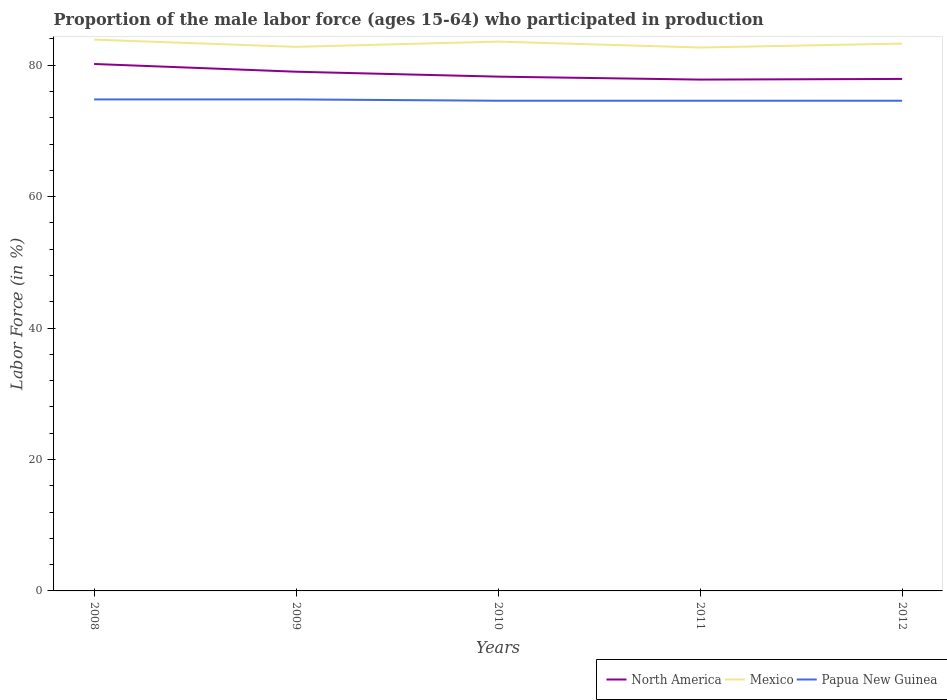How many different coloured lines are there?
Make the answer very short. 3. Across all years, what is the maximum proportion of the male labor force who participated in production in North America?
Your response must be concise. 77.82. In which year was the proportion of the male labor force who participated in production in North America maximum?
Keep it short and to the point. 2011. What is the total proportion of the male labor force who participated in production in North America in the graph?
Your answer should be very brief. -0.1. What is the difference between the highest and the second highest proportion of the male labor force who participated in production in Mexico?
Your answer should be very brief. 1.2. How many years are there in the graph?
Keep it short and to the point. 5. What is the difference between two consecutive major ticks on the Y-axis?
Offer a very short reply. 20. Does the graph contain any zero values?
Give a very brief answer. No. Where does the legend appear in the graph?
Your answer should be very brief. Bottom right. How many legend labels are there?
Give a very brief answer. 3. How are the legend labels stacked?
Ensure brevity in your answer.  Horizontal. What is the title of the graph?
Make the answer very short. Proportion of the male labor force (ages 15-64) who participated in production. What is the label or title of the X-axis?
Make the answer very short. Years. What is the label or title of the Y-axis?
Ensure brevity in your answer.  Labor Force (in %). What is the Labor Force (in %) of North America in 2008?
Ensure brevity in your answer.  80.19. What is the Labor Force (in %) of Mexico in 2008?
Give a very brief answer. 83.9. What is the Labor Force (in %) of Papua New Guinea in 2008?
Provide a short and direct response. 74.8. What is the Labor Force (in %) in North America in 2009?
Make the answer very short. 79.02. What is the Labor Force (in %) of Mexico in 2009?
Provide a short and direct response. 82.8. What is the Labor Force (in %) of Papua New Guinea in 2009?
Ensure brevity in your answer.  74.8. What is the Labor Force (in %) of North America in 2010?
Your answer should be very brief. 78.27. What is the Labor Force (in %) in Mexico in 2010?
Your response must be concise. 83.6. What is the Labor Force (in %) in Papua New Guinea in 2010?
Give a very brief answer. 74.6. What is the Labor Force (in %) of North America in 2011?
Your response must be concise. 77.82. What is the Labor Force (in %) of Mexico in 2011?
Your response must be concise. 82.7. What is the Labor Force (in %) of Papua New Guinea in 2011?
Your answer should be compact. 74.6. What is the Labor Force (in %) of North America in 2012?
Offer a terse response. 77.92. What is the Labor Force (in %) of Mexico in 2012?
Offer a terse response. 83.3. What is the Labor Force (in %) of Papua New Guinea in 2012?
Offer a terse response. 74.6. Across all years, what is the maximum Labor Force (in %) of North America?
Keep it short and to the point. 80.19. Across all years, what is the maximum Labor Force (in %) in Mexico?
Ensure brevity in your answer.  83.9. Across all years, what is the maximum Labor Force (in %) in Papua New Guinea?
Your response must be concise. 74.8. Across all years, what is the minimum Labor Force (in %) of North America?
Offer a very short reply. 77.82. Across all years, what is the minimum Labor Force (in %) of Mexico?
Provide a succinct answer. 82.7. Across all years, what is the minimum Labor Force (in %) of Papua New Guinea?
Offer a terse response. 74.6. What is the total Labor Force (in %) in North America in the graph?
Give a very brief answer. 393.21. What is the total Labor Force (in %) in Mexico in the graph?
Your response must be concise. 416.3. What is the total Labor Force (in %) of Papua New Guinea in the graph?
Make the answer very short. 373.4. What is the difference between the Labor Force (in %) in North America in 2008 and that in 2009?
Your answer should be compact. 1.18. What is the difference between the Labor Force (in %) of Papua New Guinea in 2008 and that in 2009?
Offer a terse response. 0. What is the difference between the Labor Force (in %) in North America in 2008 and that in 2010?
Make the answer very short. 1.93. What is the difference between the Labor Force (in %) in Papua New Guinea in 2008 and that in 2010?
Ensure brevity in your answer.  0.2. What is the difference between the Labor Force (in %) of North America in 2008 and that in 2011?
Offer a terse response. 2.38. What is the difference between the Labor Force (in %) in North America in 2008 and that in 2012?
Ensure brevity in your answer.  2.28. What is the difference between the Labor Force (in %) of North America in 2009 and that in 2010?
Provide a succinct answer. 0.75. What is the difference between the Labor Force (in %) of North America in 2009 and that in 2011?
Keep it short and to the point. 1.2. What is the difference between the Labor Force (in %) of Papua New Guinea in 2009 and that in 2011?
Provide a succinct answer. 0.2. What is the difference between the Labor Force (in %) in North America in 2009 and that in 2012?
Provide a short and direct response. 1.1. What is the difference between the Labor Force (in %) in Mexico in 2009 and that in 2012?
Offer a terse response. -0.5. What is the difference between the Labor Force (in %) of Papua New Guinea in 2009 and that in 2012?
Your answer should be very brief. 0.2. What is the difference between the Labor Force (in %) in North America in 2010 and that in 2011?
Your response must be concise. 0.45. What is the difference between the Labor Force (in %) of Papua New Guinea in 2010 and that in 2011?
Your answer should be very brief. 0. What is the difference between the Labor Force (in %) of North America in 2010 and that in 2012?
Offer a very short reply. 0.35. What is the difference between the Labor Force (in %) in North America in 2011 and that in 2012?
Your answer should be very brief. -0.1. What is the difference between the Labor Force (in %) of Mexico in 2011 and that in 2012?
Ensure brevity in your answer.  -0.6. What is the difference between the Labor Force (in %) in Papua New Guinea in 2011 and that in 2012?
Keep it short and to the point. 0. What is the difference between the Labor Force (in %) in North America in 2008 and the Labor Force (in %) in Mexico in 2009?
Your answer should be very brief. -2.61. What is the difference between the Labor Force (in %) of North America in 2008 and the Labor Force (in %) of Papua New Guinea in 2009?
Give a very brief answer. 5.39. What is the difference between the Labor Force (in %) in Mexico in 2008 and the Labor Force (in %) in Papua New Guinea in 2009?
Give a very brief answer. 9.1. What is the difference between the Labor Force (in %) of North America in 2008 and the Labor Force (in %) of Mexico in 2010?
Your answer should be compact. -3.41. What is the difference between the Labor Force (in %) of North America in 2008 and the Labor Force (in %) of Papua New Guinea in 2010?
Give a very brief answer. 5.59. What is the difference between the Labor Force (in %) in Mexico in 2008 and the Labor Force (in %) in Papua New Guinea in 2010?
Give a very brief answer. 9.3. What is the difference between the Labor Force (in %) of North America in 2008 and the Labor Force (in %) of Mexico in 2011?
Offer a terse response. -2.51. What is the difference between the Labor Force (in %) of North America in 2008 and the Labor Force (in %) of Papua New Guinea in 2011?
Offer a very short reply. 5.59. What is the difference between the Labor Force (in %) in Mexico in 2008 and the Labor Force (in %) in Papua New Guinea in 2011?
Provide a succinct answer. 9.3. What is the difference between the Labor Force (in %) in North America in 2008 and the Labor Force (in %) in Mexico in 2012?
Keep it short and to the point. -3.11. What is the difference between the Labor Force (in %) in North America in 2008 and the Labor Force (in %) in Papua New Guinea in 2012?
Ensure brevity in your answer.  5.59. What is the difference between the Labor Force (in %) of North America in 2009 and the Labor Force (in %) of Mexico in 2010?
Provide a succinct answer. -4.58. What is the difference between the Labor Force (in %) of North America in 2009 and the Labor Force (in %) of Papua New Guinea in 2010?
Give a very brief answer. 4.42. What is the difference between the Labor Force (in %) of Mexico in 2009 and the Labor Force (in %) of Papua New Guinea in 2010?
Make the answer very short. 8.2. What is the difference between the Labor Force (in %) in North America in 2009 and the Labor Force (in %) in Mexico in 2011?
Keep it short and to the point. -3.68. What is the difference between the Labor Force (in %) of North America in 2009 and the Labor Force (in %) of Papua New Guinea in 2011?
Offer a terse response. 4.42. What is the difference between the Labor Force (in %) in North America in 2009 and the Labor Force (in %) in Mexico in 2012?
Provide a succinct answer. -4.28. What is the difference between the Labor Force (in %) in North America in 2009 and the Labor Force (in %) in Papua New Guinea in 2012?
Provide a succinct answer. 4.42. What is the difference between the Labor Force (in %) of North America in 2010 and the Labor Force (in %) of Mexico in 2011?
Give a very brief answer. -4.43. What is the difference between the Labor Force (in %) of North America in 2010 and the Labor Force (in %) of Papua New Guinea in 2011?
Offer a very short reply. 3.67. What is the difference between the Labor Force (in %) in Mexico in 2010 and the Labor Force (in %) in Papua New Guinea in 2011?
Your answer should be compact. 9. What is the difference between the Labor Force (in %) in North America in 2010 and the Labor Force (in %) in Mexico in 2012?
Ensure brevity in your answer.  -5.03. What is the difference between the Labor Force (in %) in North America in 2010 and the Labor Force (in %) in Papua New Guinea in 2012?
Your response must be concise. 3.67. What is the difference between the Labor Force (in %) of North America in 2011 and the Labor Force (in %) of Mexico in 2012?
Your answer should be compact. -5.48. What is the difference between the Labor Force (in %) in North America in 2011 and the Labor Force (in %) in Papua New Guinea in 2012?
Provide a succinct answer. 3.22. What is the average Labor Force (in %) of North America per year?
Provide a short and direct response. 78.64. What is the average Labor Force (in %) in Mexico per year?
Offer a terse response. 83.26. What is the average Labor Force (in %) of Papua New Guinea per year?
Ensure brevity in your answer.  74.68. In the year 2008, what is the difference between the Labor Force (in %) of North America and Labor Force (in %) of Mexico?
Ensure brevity in your answer.  -3.71. In the year 2008, what is the difference between the Labor Force (in %) in North America and Labor Force (in %) in Papua New Guinea?
Offer a very short reply. 5.39. In the year 2008, what is the difference between the Labor Force (in %) in Mexico and Labor Force (in %) in Papua New Guinea?
Give a very brief answer. 9.1. In the year 2009, what is the difference between the Labor Force (in %) in North America and Labor Force (in %) in Mexico?
Your answer should be compact. -3.78. In the year 2009, what is the difference between the Labor Force (in %) in North America and Labor Force (in %) in Papua New Guinea?
Offer a terse response. 4.22. In the year 2009, what is the difference between the Labor Force (in %) of Mexico and Labor Force (in %) of Papua New Guinea?
Ensure brevity in your answer.  8. In the year 2010, what is the difference between the Labor Force (in %) of North America and Labor Force (in %) of Mexico?
Your response must be concise. -5.33. In the year 2010, what is the difference between the Labor Force (in %) of North America and Labor Force (in %) of Papua New Guinea?
Provide a succinct answer. 3.67. In the year 2011, what is the difference between the Labor Force (in %) of North America and Labor Force (in %) of Mexico?
Make the answer very short. -4.88. In the year 2011, what is the difference between the Labor Force (in %) in North America and Labor Force (in %) in Papua New Guinea?
Provide a short and direct response. 3.22. In the year 2011, what is the difference between the Labor Force (in %) in Mexico and Labor Force (in %) in Papua New Guinea?
Keep it short and to the point. 8.1. In the year 2012, what is the difference between the Labor Force (in %) of North America and Labor Force (in %) of Mexico?
Give a very brief answer. -5.38. In the year 2012, what is the difference between the Labor Force (in %) in North America and Labor Force (in %) in Papua New Guinea?
Your response must be concise. 3.32. In the year 2012, what is the difference between the Labor Force (in %) of Mexico and Labor Force (in %) of Papua New Guinea?
Your answer should be compact. 8.7. What is the ratio of the Labor Force (in %) of North America in 2008 to that in 2009?
Keep it short and to the point. 1.01. What is the ratio of the Labor Force (in %) in Mexico in 2008 to that in 2009?
Your answer should be compact. 1.01. What is the ratio of the Labor Force (in %) in Papua New Guinea in 2008 to that in 2009?
Offer a terse response. 1. What is the ratio of the Labor Force (in %) of North America in 2008 to that in 2010?
Ensure brevity in your answer.  1.02. What is the ratio of the Labor Force (in %) of North America in 2008 to that in 2011?
Offer a very short reply. 1.03. What is the ratio of the Labor Force (in %) in Mexico in 2008 to that in 2011?
Provide a short and direct response. 1.01. What is the ratio of the Labor Force (in %) in North America in 2008 to that in 2012?
Keep it short and to the point. 1.03. What is the ratio of the Labor Force (in %) in Mexico in 2008 to that in 2012?
Keep it short and to the point. 1.01. What is the ratio of the Labor Force (in %) in Papua New Guinea in 2008 to that in 2012?
Provide a succinct answer. 1. What is the ratio of the Labor Force (in %) of North America in 2009 to that in 2010?
Your response must be concise. 1.01. What is the ratio of the Labor Force (in %) of Mexico in 2009 to that in 2010?
Your answer should be compact. 0.99. What is the ratio of the Labor Force (in %) of Papua New Guinea in 2009 to that in 2010?
Give a very brief answer. 1. What is the ratio of the Labor Force (in %) of North America in 2009 to that in 2011?
Your answer should be compact. 1.02. What is the ratio of the Labor Force (in %) of Mexico in 2009 to that in 2011?
Keep it short and to the point. 1. What is the ratio of the Labor Force (in %) in Papua New Guinea in 2009 to that in 2011?
Keep it short and to the point. 1. What is the ratio of the Labor Force (in %) of North America in 2009 to that in 2012?
Keep it short and to the point. 1.01. What is the ratio of the Labor Force (in %) in Papua New Guinea in 2009 to that in 2012?
Your answer should be very brief. 1. What is the ratio of the Labor Force (in %) in North America in 2010 to that in 2011?
Give a very brief answer. 1.01. What is the ratio of the Labor Force (in %) of Mexico in 2010 to that in 2011?
Offer a very short reply. 1.01. What is the ratio of the Labor Force (in %) of Papua New Guinea in 2010 to that in 2011?
Give a very brief answer. 1. What is the ratio of the Labor Force (in %) of North America in 2010 to that in 2012?
Offer a terse response. 1. What is the ratio of the Labor Force (in %) of Mexico in 2010 to that in 2012?
Provide a short and direct response. 1. What is the ratio of the Labor Force (in %) of Papua New Guinea in 2010 to that in 2012?
Your response must be concise. 1. What is the ratio of the Labor Force (in %) in North America in 2011 to that in 2012?
Provide a short and direct response. 1. What is the ratio of the Labor Force (in %) in Papua New Guinea in 2011 to that in 2012?
Ensure brevity in your answer.  1. What is the difference between the highest and the second highest Labor Force (in %) of North America?
Offer a terse response. 1.18. What is the difference between the highest and the second highest Labor Force (in %) of Mexico?
Make the answer very short. 0.3. What is the difference between the highest and the second highest Labor Force (in %) of Papua New Guinea?
Make the answer very short. 0. What is the difference between the highest and the lowest Labor Force (in %) of North America?
Your response must be concise. 2.38. What is the difference between the highest and the lowest Labor Force (in %) in Mexico?
Offer a terse response. 1.2. 